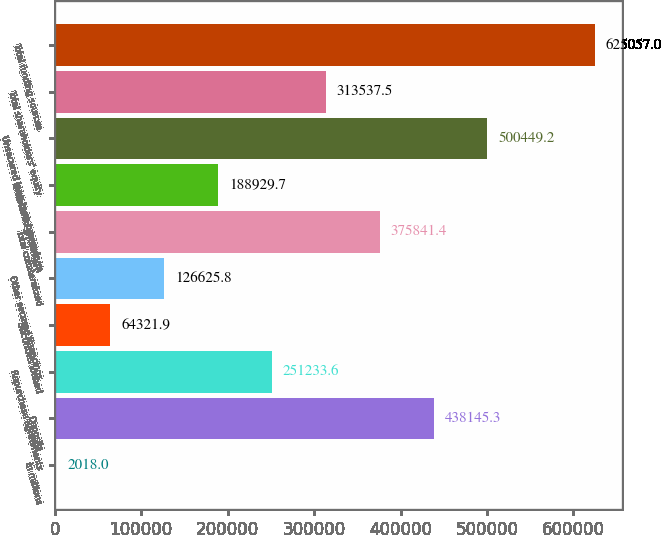Convert chart to OTSL. <chart><loc_0><loc_0><loc_500><loc_500><bar_chart><fcel>in millions<fcel>Deposits<fcel>Repurchase agreements<fcel>Securities loaned<fcel>Other secured financings<fcel>Total collateralized<fcel>Unsecured short-term<fcel>Unsecured long-term borrowings<fcel>Total shareholders' equity<fcel>Total funding sources<nl><fcel>2018<fcel>438145<fcel>251234<fcel>64321.9<fcel>126626<fcel>375841<fcel>188930<fcel>500449<fcel>313538<fcel>625057<nl></chart> 